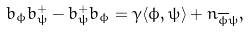<formula> <loc_0><loc_0><loc_500><loc_500>b _ { \phi } b ^ { + } _ { \psi } - b ^ { + } _ { \psi } b _ { \phi } = \gamma \langle \phi , \psi \rangle + n _ { \overline { \phi } \psi } ,</formula> 